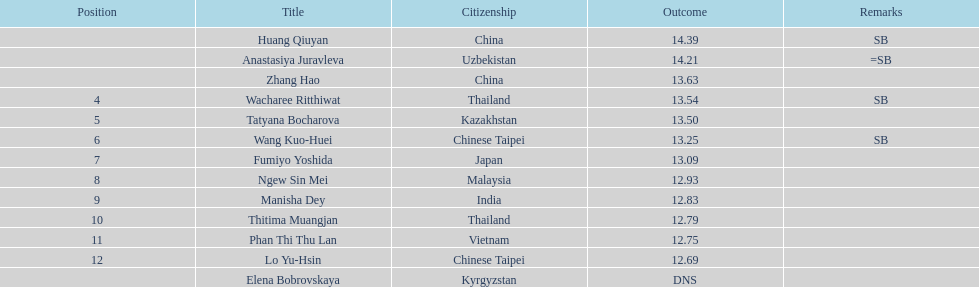How many contestants were from thailand? 2. 